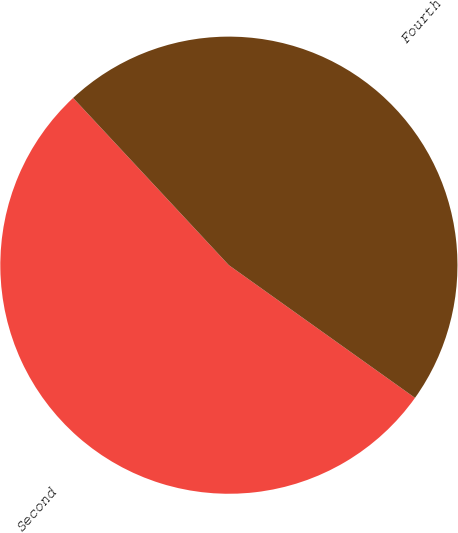Convert chart to OTSL. <chart><loc_0><loc_0><loc_500><loc_500><pie_chart><fcel>Second<fcel>Fourth<nl><fcel>53.21%<fcel>46.79%<nl></chart> 